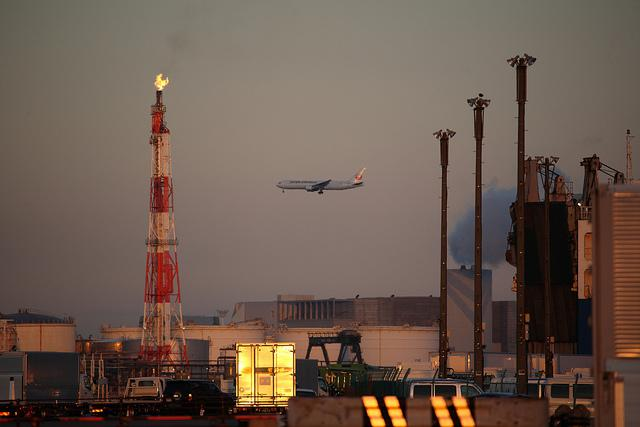What is coming out of the red and white tower? fire 